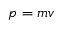<formula> <loc_0><loc_0><loc_500><loc_500>p = m v</formula> 